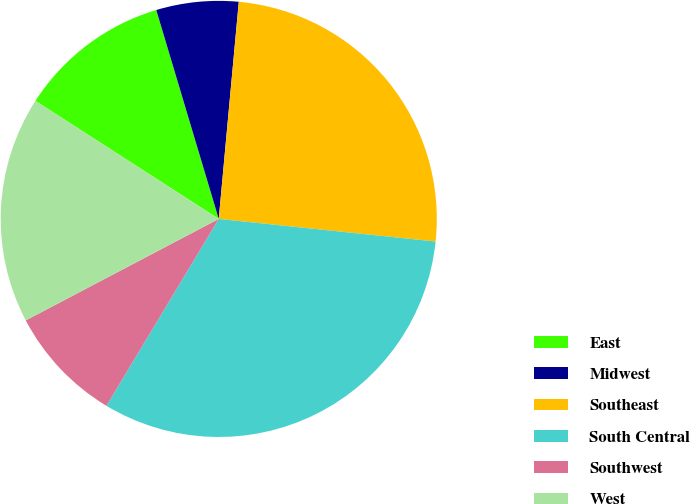Convert chart to OTSL. <chart><loc_0><loc_0><loc_500><loc_500><pie_chart><fcel>East<fcel>Midwest<fcel>Southeast<fcel>South Central<fcel>Southwest<fcel>West<nl><fcel>11.27%<fcel>6.09%<fcel>25.19%<fcel>31.96%<fcel>8.68%<fcel>16.81%<nl></chart> 